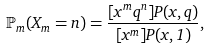<formula> <loc_0><loc_0><loc_500><loc_500>\mathbb { P } _ { m } ( X _ { m } = n ) = \frac { [ x ^ { m } q ^ { n } ] P ( x , q ) } { [ x ^ { m } ] P ( x , 1 ) } ,</formula> 